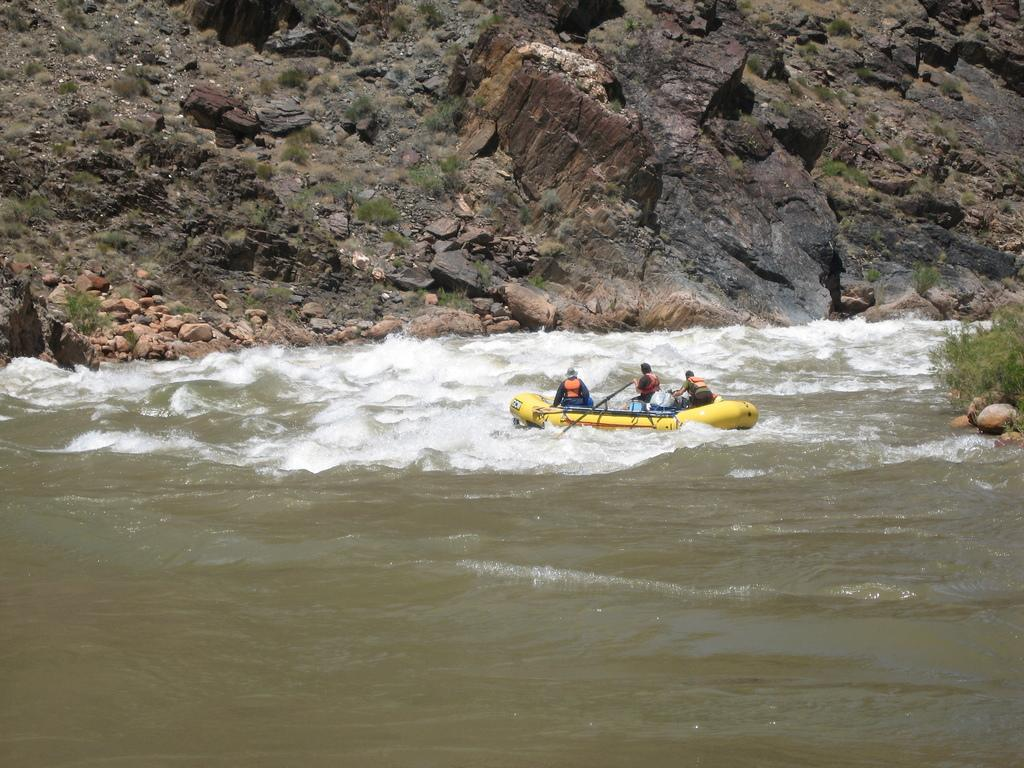What is the main subject of the image? The main subject of the image is a boat. Where is the boat located? The boat is on the water. How many people are on the boat? There are three people on the boat. What else can be seen on the boat? There are objects on the boat. What can be seen in the background of the image? There are stones and plants visible in the background of the image. What is the name of the person feeling shame on the boat in the image? There is no indication of anyone feeling shame in the image, and therefore no such person can be identified. 